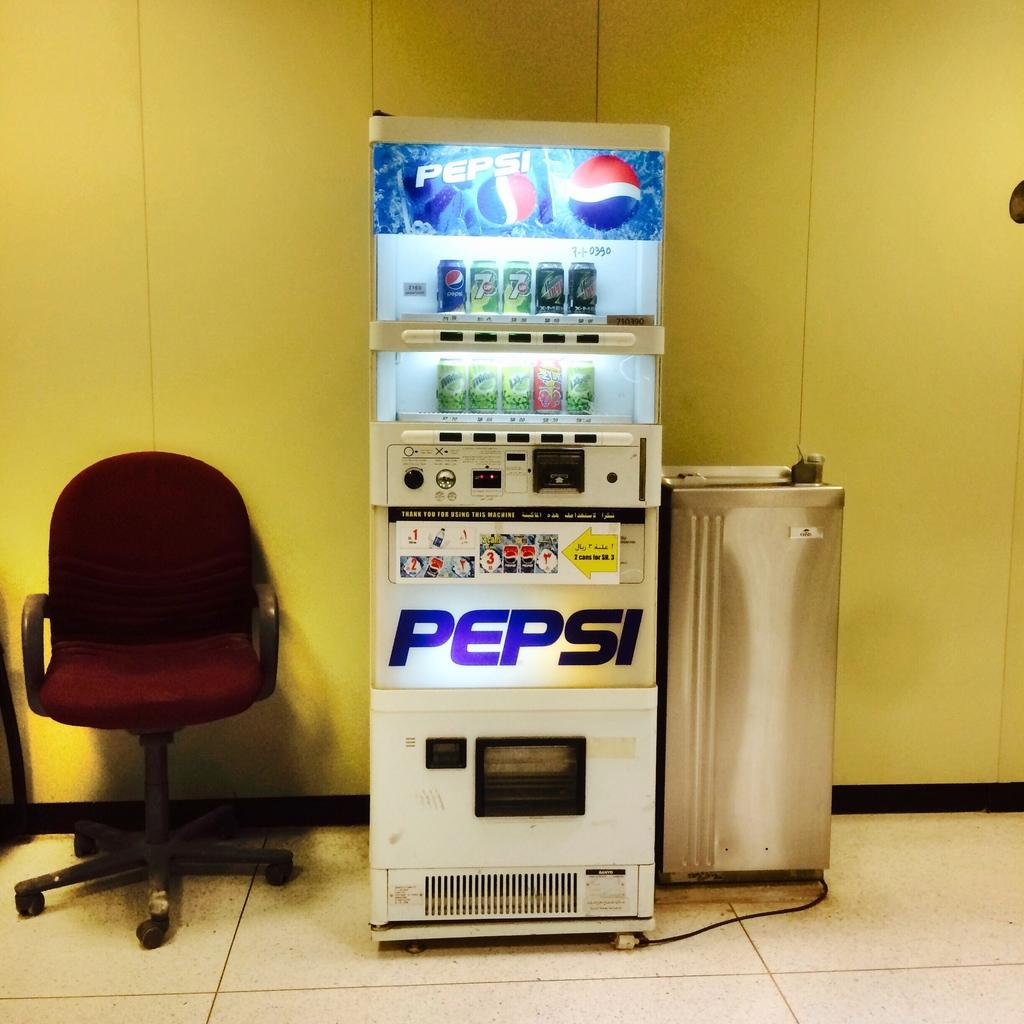Provide a one-sentence caption for the provided image. pepsi soda machine sits in a room with yellow walls. 